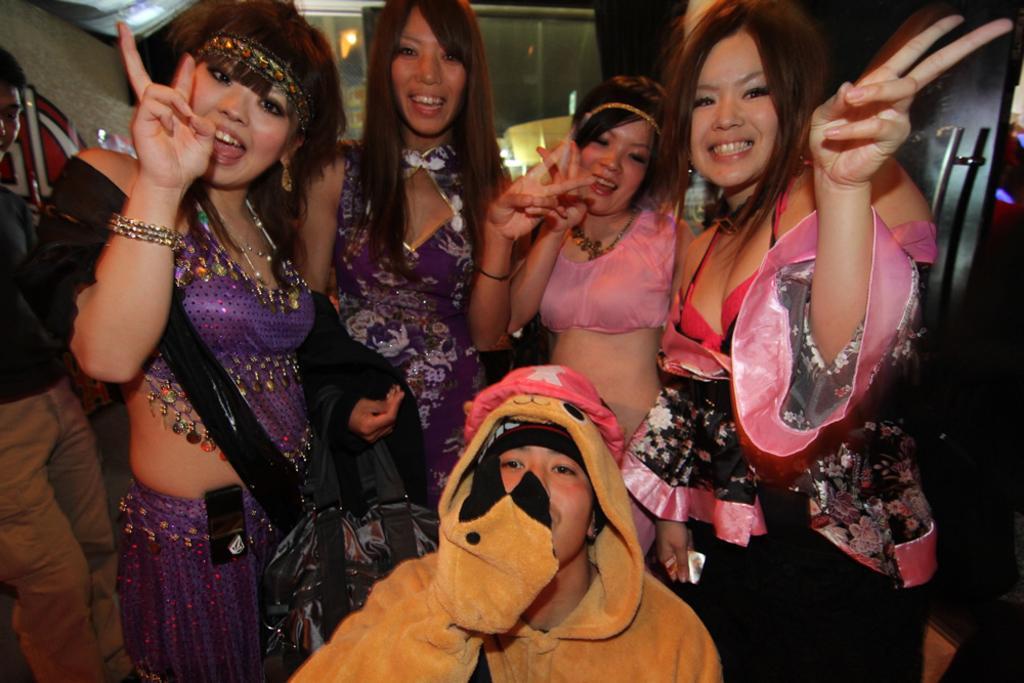Please provide a concise description of this image. There are four women standing and posing for the photo. At the bottom, we see the man in the yellow jacket is sitting. Behind them, we see a wall and on the right side, there is a brown door. This picture is clicked inside the room. 